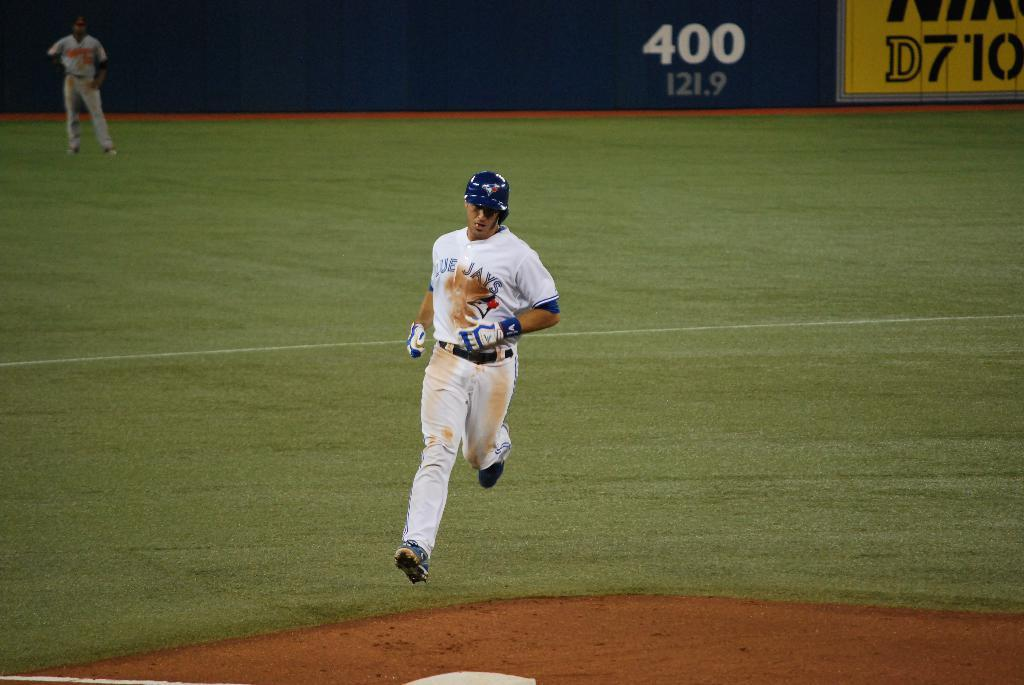Provide a one-sentence caption for the provided image. A Blue Jays player running on the field. 